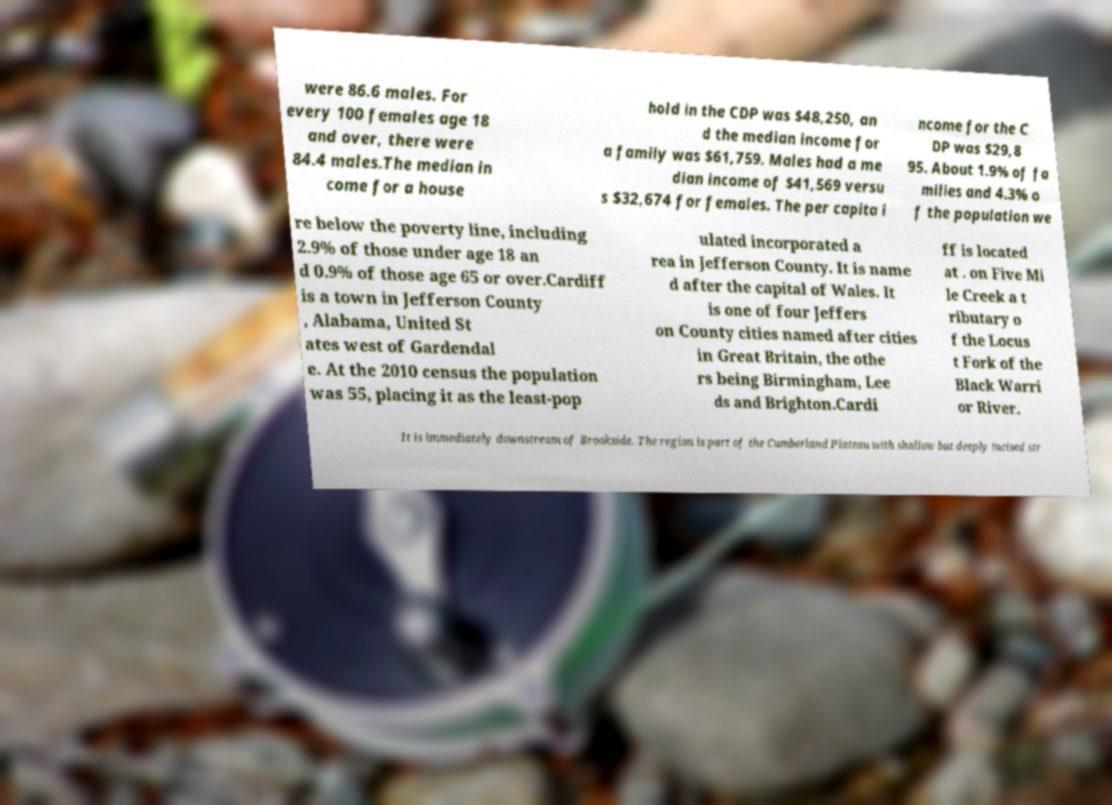Please identify and transcribe the text found in this image. were 86.6 males. For every 100 females age 18 and over, there were 84.4 males.The median in come for a house hold in the CDP was $48,250, an d the median income for a family was $61,759. Males had a me dian income of $41,569 versu s $32,674 for females. The per capita i ncome for the C DP was $29,8 95. About 1.9% of fa milies and 4.3% o f the population we re below the poverty line, including 2.9% of those under age 18 an d 0.9% of those age 65 or over.Cardiff is a town in Jefferson County , Alabama, United St ates west of Gardendal e. At the 2010 census the population was 55, placing it as the least-pop ulated incorporated a rea in Jefferson County. It is name d after the capital of Wales. It is one of four Jeffers on County cities named after cities in Great Britain, the othe rs being Birmingham, Lee ds and Brighton.Cardi ff is located at . on Five Mi le Creek a t ributary o f the Locus t Fork of the Black Warri or River. It is immediately downstream of Brookside. The region is part of the Cumberland Plateau with shallow but deeply incised str 